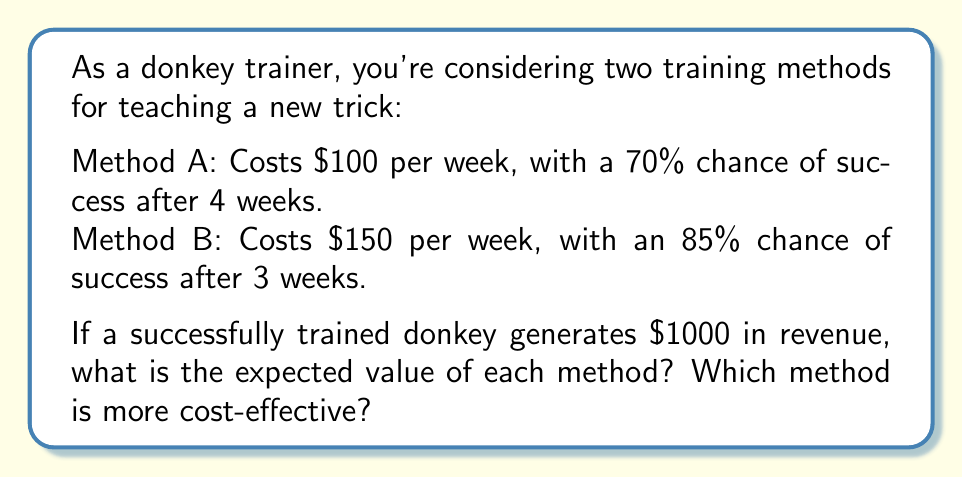What is the answer to this math problem? Let's calculate the expected value for each method:

Method A:
1. Cost: $100 × 4 weeks = $400
2. Probability of success: 70% = 0.7
3. Expected revenue: $1000 × 0.7 = $700
4. Expected value: Revenue - Cost
   $$ EV_A = 700 - 400 = $300 $$

Method B:
1. Cost: $150 × 3 weeks = $450
2. Probability of success: 85% = 0.85
3. Expected revenue: $1000 × 0.85 = $850
4. Expected value: Revenue - Cost
   $$ EV_B = 850 - 450 = $400 $$

To determine cost-effectiveness, we can calculate the return on investment (ROI) for each method:

$$ ROI = \frac{\text{Expected Value}}{\text{Cost}} \times 100\% $$

Method A ROI:
$$ ROI_A = \frac{300}{400} \times 100\% = 75\% $$

Method B ROI:
$$ ROI_B = \frac{400}{450} \times 100\% = 88.89\% $$

Method B has a higher expected value ($400 vs $300) and a higher ROI (88.89% vs 75%), making it more cost-effective.
Answer: Method B; EV: $400, ROI: 88.89% 